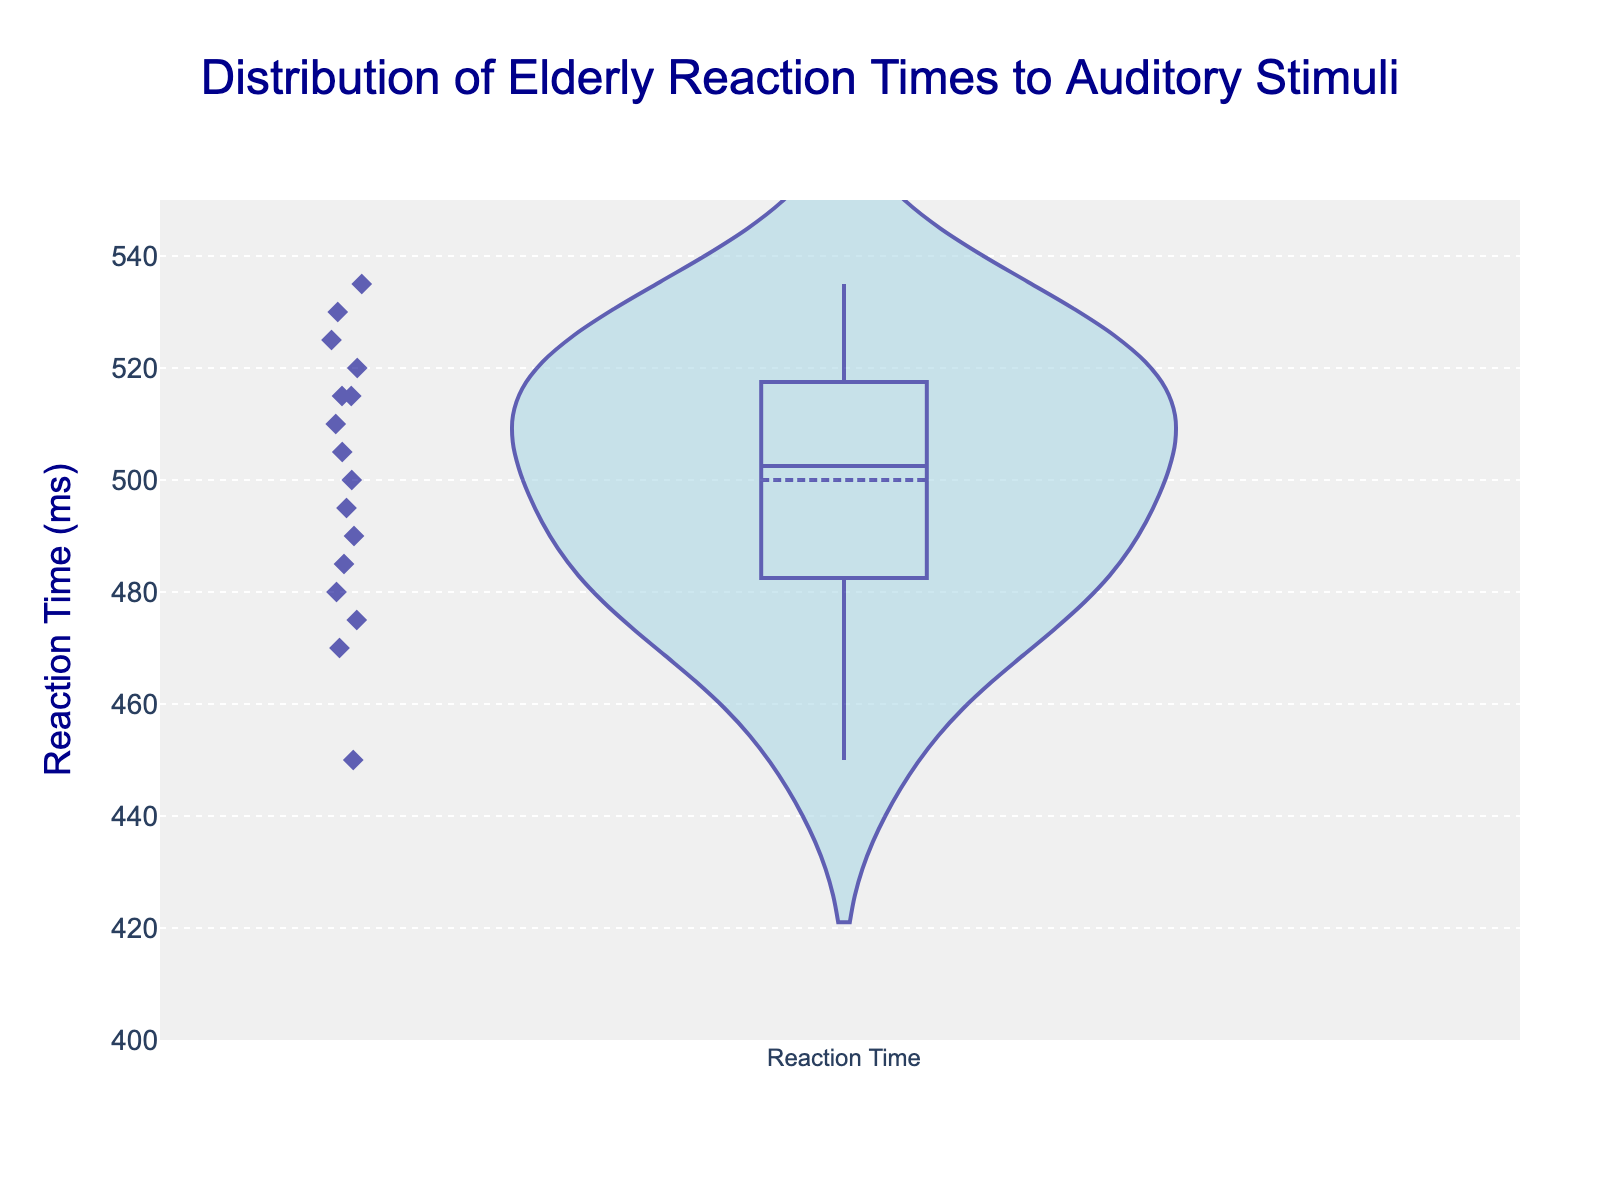What's the title of the plot? The title is displayed at the top of the plot, centered and in a larger font size. It describes what the plot is showing.
Answer: Distribution of Elderly Reaction Times to Auditory Stimuli What is the range of reaction times shown on the y-axis? The y-axis range is indicated by the numerical values at the top and bottom of the y-axis.
Answer: 400 to 550 ms How many subjects' reaction times are displayed in the plot? Count the number of individual points or markers displayed to represent each subject.
Answer: 16 What color represents the density of reaction times? The color used for the density plot is typically shown in the plot itself, filled around the highest concentration of data points.
Answer: Light blue What's the mean reaction time shown in the plot? The mean reaction time is typically indicated by a mean line (often in a different color or style) in the violin plot.
Answer: Approximately 497.5 ms (mid-point between 400 ms and 550 ms) Which subject has the highest reaction time, and what is that time? Locate the highest point on the density plot and find its corresponding y-axis value.
Answer: Barbara Harris; 535 ms What's the median reaction time? The median reaction time can be inferred by looking at the distribution and identifying the middle value where 50% of data points lie above and 50% below.
Answer: Approximately 505 ms What's the interquartile range (IQR) of the reaction times? The IQR is the range between the 25th and 75th percentiles. In a violin plot, this can usually be visually estimated by looking at the spread of data points around the median line.
Answer: Approximately 470 ms to 520 ms Are there any outliers in the reaction times? Outliers in a violin plot are often displayed as individual dots outside the range of a typical distribution. Check for any points that stand out significantly further from the concentrations.
Answer: No significant outliers Who has a reaction time closest to the average reaction time? Compare the individual data points to the mean line to find the subject's point closest to the mean reaction time.
Answer: James Anderson; 495 ms 